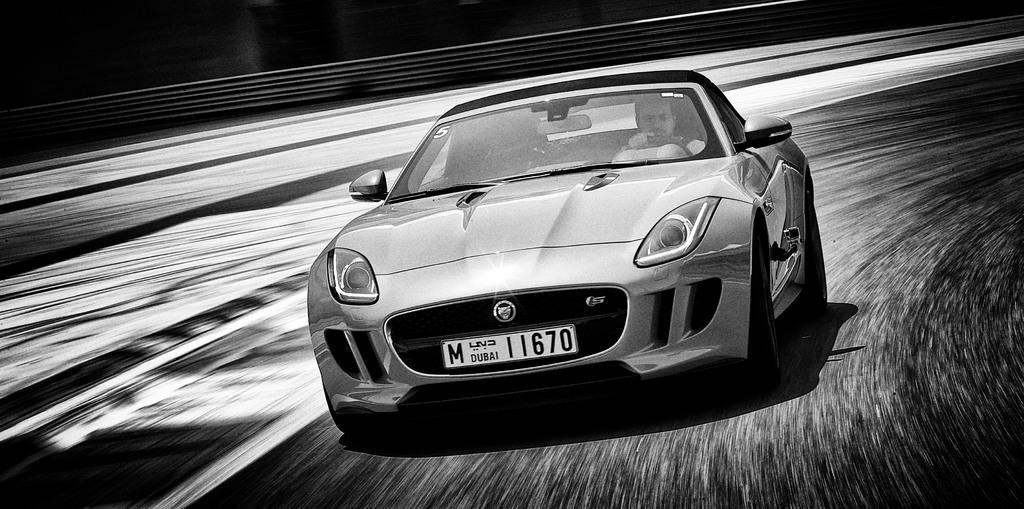Who is present in the image? There is a man in the image. What is the man doing in the image? The man is riding a car in the image. Where is the car located? The car is on a road in the image. What can be seen at the top of the image? There appears to be a fence at the top of the image. What type of committee is meeting in the image? There is no committee meeting in the image; it features a man riding a car on a road. Can you tell me how many bikes are present in the image? There are no bikes present in the image; it features a man riding a car. 